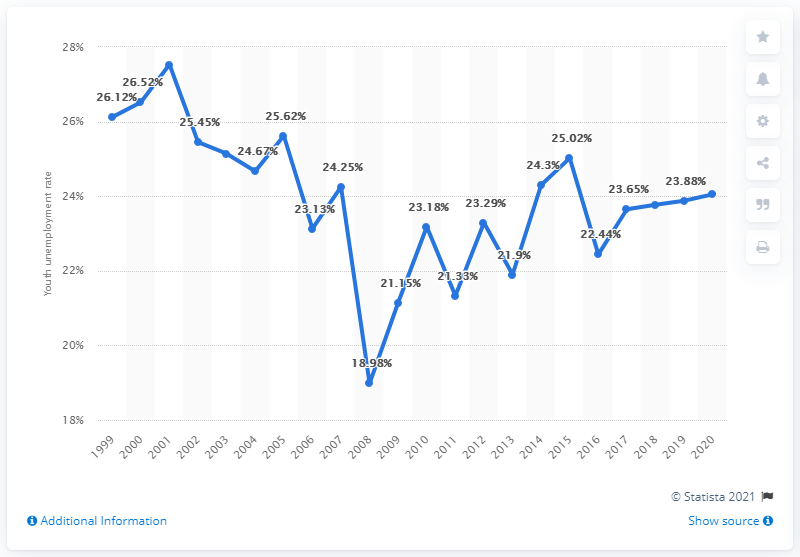Specify some key components in this picture. In 2020, the youth unemployment rate in Mauritius was 24.05%. 